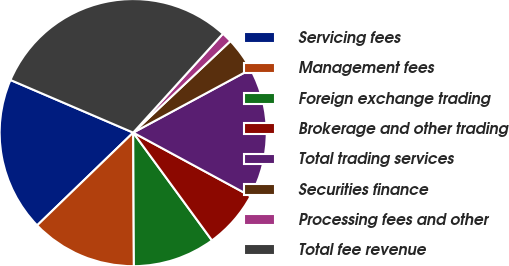<chart> <loc_0><loc_0><loc_500><loc_500><pie_chart><fcel>Servicing fees<fcel>Management fees<fcel>Foreign exchange trading<fcel>Brokerage and other trading<fcel>Total trading services<fcel>Securities finance<fcel>Processing fees and other<fcel>Total fee revenue<nl><fcel>18.67%<fcel>12.86%<fcel>9.96%<fcel>7.06%<fcel>15.77%<fcel>4.15%<fcel>1.25%<fcel>30.28%<nl></chart> 